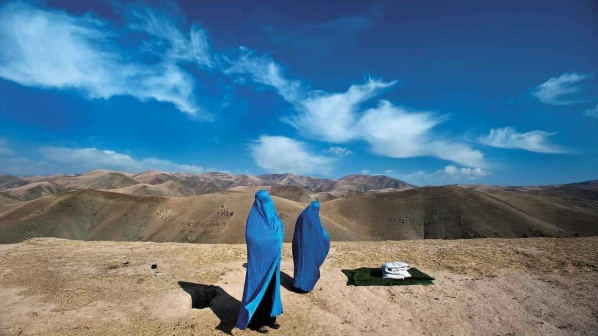What if the women discovered an ancient artifact in this spot? As Saira and Anisa were about to leave the hilltop, Saira's foot brushed against something hard buried in the earth. Scraping away the loose dirt, they unearthed an ancient box, intricately carved with symbols unknown to them. The box, though aged, had a mysterious allure. Carefully, they opened it and found inside a collection of scrolls, tied with faded ribbons. The scrolls, written in an ancient script, seemed to tell a story of the land and its hidden powers.

Realizing the potential significance, they decided to take the box with them, knowing that it could hold the key to deeper knowledge and perhaps the very secrets they sought in their pilgrimage. The discovery revitalized their spirits, adding a new layer of purpose to their journey. They now carried not just their provisions but the weight of history, feeling a stronger connection to the land and its ancient inhabitants. 